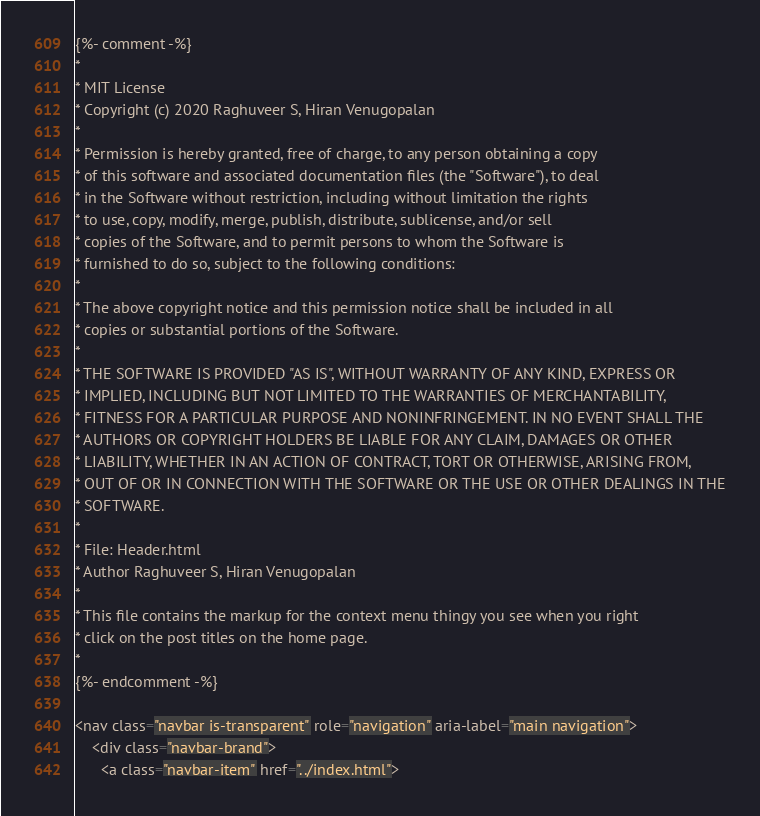<code> <loc_0><loc_0><loc_500><loc_500><_HTML_>{%- comment -%}
*
* MIT License
* Copyright (c) 2020 Raghuveer S, Hiran Venugopalan
*
* Permission is hereby granted, free of charge, to any person obtaining a copy
* of this software and associated documentation files (the "Software"), to deal
* in the Software without restriction, including without limitation the rights
* to use, copy, modify, merge, publish, distribute, sublicense, and/or sell
* copies of the Software, and to permit persons to whom the Software is
* furnished to do so, subject to the following conditions:
*
* The above copyright notice and this permission notice shall be included in all
* copies or substantial portions of the Software.
*
* THE SOFTWARE IS PROVIDED "AS IS", WITHOUT WARRANTY OF ANY KIND, EXPRESS OR
* IMPLIED, INCLUDING BUT NOT LIMITED TO THE WARRANTIES OF MERCHANTABILITY,
* FITNESS FOR A PARTICULAR PURPOSE AND NONINFRINGEMENT. IN NO EVENT SHALL THE
* AUTHORS OR COPYRIGHT HOLDERS BE LIABLE FOR ANY CLAIM, DAMAGES OR OTHER
* LIABILITY, WHETHER IN AN ACTION OF CONTRACT, TORT OR OTHERWISE, ARISING FROM,
* OUT OF OR IN CONNECTION WITH THE SOFTWARE OR THE USE OR OTHER DEALINGS IN THE
* SOFTWARE.
*
* File: Header.html
* Author Raghuveer S, Hiran Venugopalan
*
* This file contains the markup for the context menu thingy you see when you right
* click on the post titles on the home page.
*
{%- endcomment -%}

<nav class="navbar is-transparent" role="navigation" aria-label="main navigation">
    <div class="navbar-brand">
      <a class="navbar-item" href="../index.html"></code> 